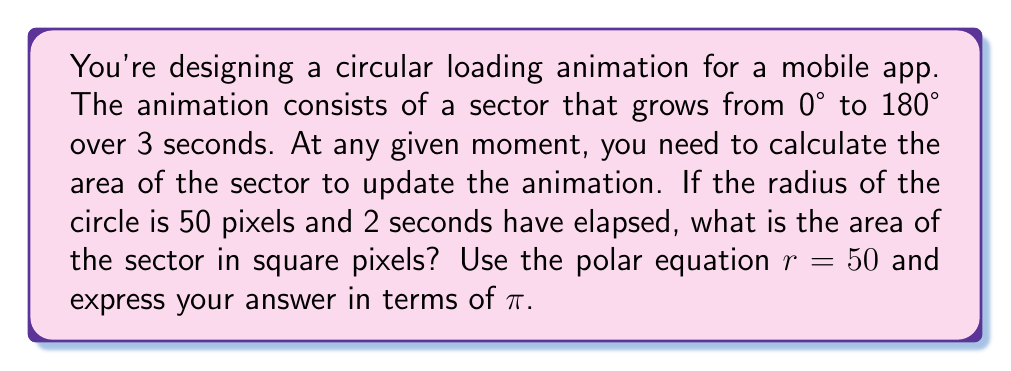Give your solution to this math problem. Let's approach this step-by-step:

1) First, we need to determine the angle $\theta$ of the sector after 2 seconds:
   - The animation goes from 0° to 180° in 3 seconds
   - So after 2 seconds, the angle is: $\theta = 180° \cdot \frac{2}{3} = 120°$

2) Convert 120° to radians:
   $\theta = 120° \cdot \frac{\pi}{180°} = \frac{2\pi}{3}$ radians

3) The formula for the area of a sector in polar coordinates is:
   $$A = \frac{1}{2} \int_0^\theta r^2 d\theta$$

4) In this case, $r$ is constant (50 pixels), so we can simplify:
   $$A = \frac{1}{2} r^2 \int_0^\theta d\theta = \frac{1}{2} r^2 \theta$$

5) Substituting our values:
   $$A = \frac{1}{2} \cdot 50^2 \cdot \frac{2\pi}{3}$$

6) Simplify:
   $$A = \frac{1}{2} \cdot 2500 \cdot \frac{2\pi}{3} = \frac{2500\pi}{3}$$

Therefore, the area of the sector after 2 seconds is $\frac{2500\pi}{3}$ square pixels.
Answer: $\frac{2500\pi}{3}$ square pixels 